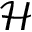Convert formula to latex. <formula><loc_0><loc_0><loc_500><loc_500>\mathcal { H }</formula> 